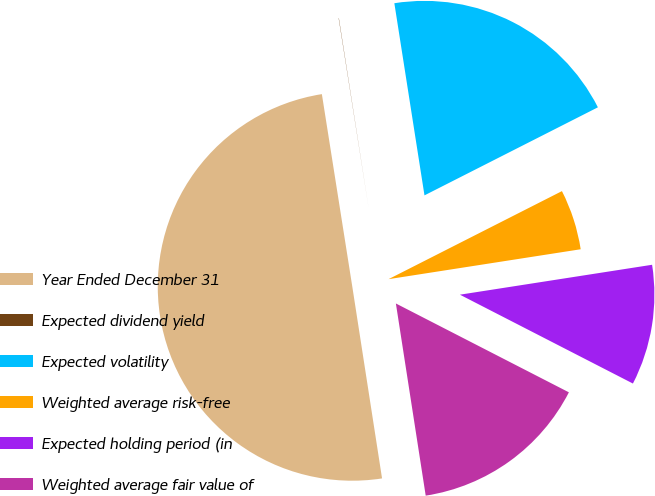<chart> <loc_0><loc_0><loc_500><loc_500><pie_chart><fcel>Year Ended December 31<fcel>Expected dividend yield<fcel>Expected volatility<fcel>Weighted average risk-free<fcel>Expected holding period (in<fcel>Weighted average fair value of<nl><fcel>49.96%<fcel>0.02%<fcel>20.0%<fcel>5.02%<fcel>10.01%<fcel>15.0%<nl></chart> 